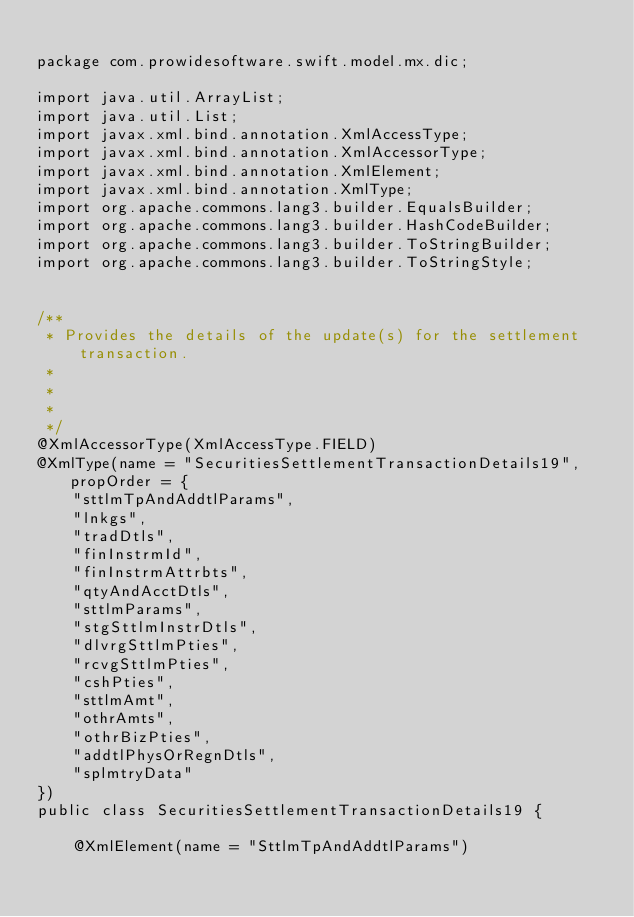Convert code to text. <code><loc_0><loc_0><loc_500><loc_500><_Java_>
package com.prowidesoftware.swift.model.mx.dic;

import java.util.ArrayList;
import java.util.List;
import javax.xml.bind.annotation.XmlAccessType;
import javax.xml.bind.annotation.XmlAccessorType;
import javax.xml.bind.annotation.XmlElement;
import javax.xml.bind.annotation.XmlType;
import org.apache.commons.lang3.builder.EqualsBuilder;
import org.apache.commons.lang3.builder.HashCodeBuilder;
import org.apache.commons.lang3.builder.ToStringBuilder;
import org.apache.commons.lang3.builder.ToStringStyle;


/**
 * Provides the details of the update(s) for the settlement transaction.
 * 
 * 
 * 
 */
@XmlAccessorType(XmlAccessType.FIELD)
@XmlType(name = "SecuritiesSettlementTransactionDetails19", propOrder = {
    "sttlmTpAndAddtlParams",
    "lnkgs",
    "tradDtls",
    "finInstrmId",
    "finInstrmAttrbts",
    "qtyAndAcctDtls",
    "sttlmParams",
    "stgSttlmInstrDtls",
    "dlvrgSttlmPties",
    "rcvgSttlmPties",
    "cshPties",
    "sttlmAmt",
    "othrAmts",
    "othrBizPties",
    "addtlPhysOrRegnDtls",
    "splmtryData"
})
public class SecuritiesSettlementTransactionDetails19 {

    @XmlElement(name = "SttlmTpAndAddtlParams")</code> 